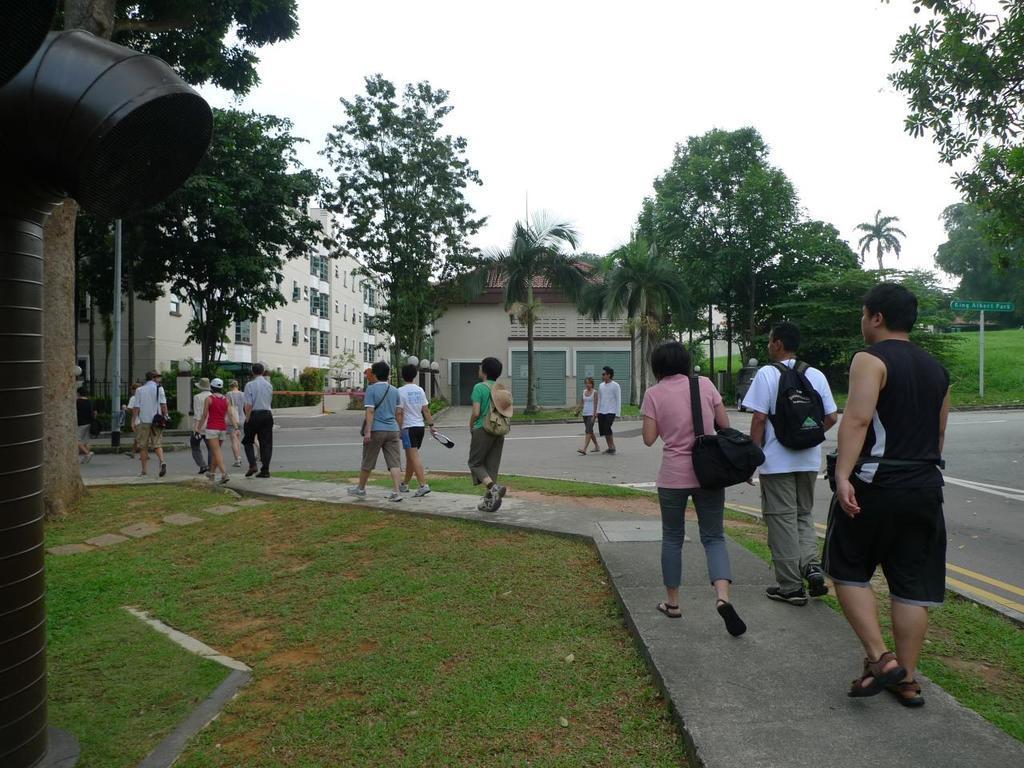Please provide a concise description of this image. In this picture I can see group of people standing, there are poles, board, pipe, plants, grass, trees, houses, shutters, and in the background there is sky. 